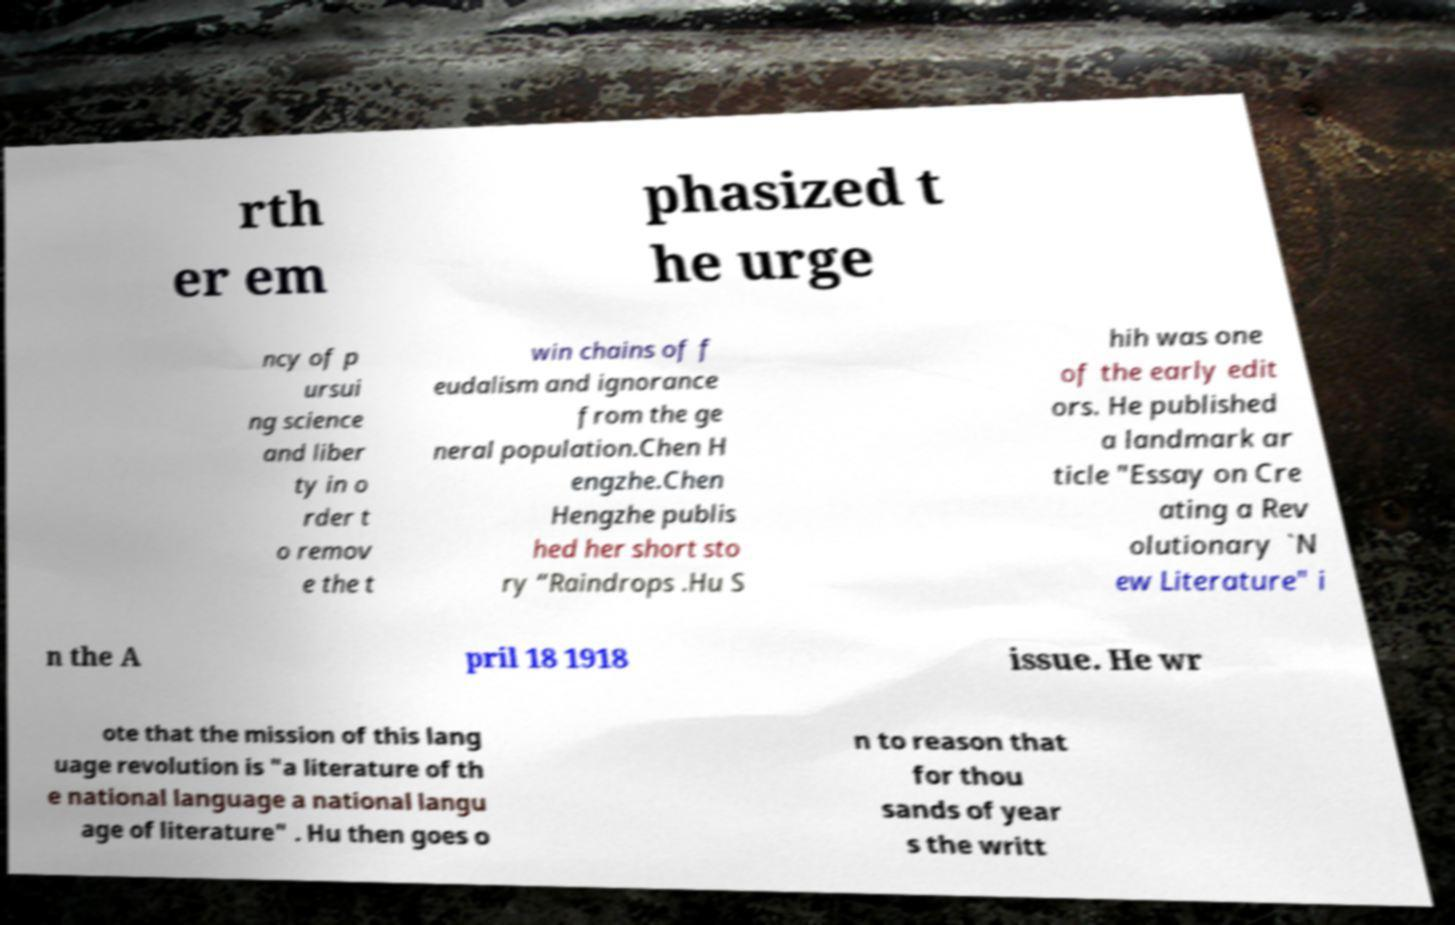Could you extract and type out the text from this image? rth er em phasized t he urge ncy of p ursui ng science and liber ty in o rder t o remov e the t win chains of f eudalism and ignorance from the ge neral population.Chen H engzhe.Chen Hengzhe publis hed her short sto ry “Raindrops .Hu S hih was one of the early edit ors. He published a landmark ar ticle "Essay on Cre ating a Rev olutionary `N ew Literature" i n the A pril 18 1918 issue. He wr ote that the mission of this lang uage revolution is "a literature of th e national language a national langu age of literature" . Hu then goes o n to reason that for thou sands of year s the writt 